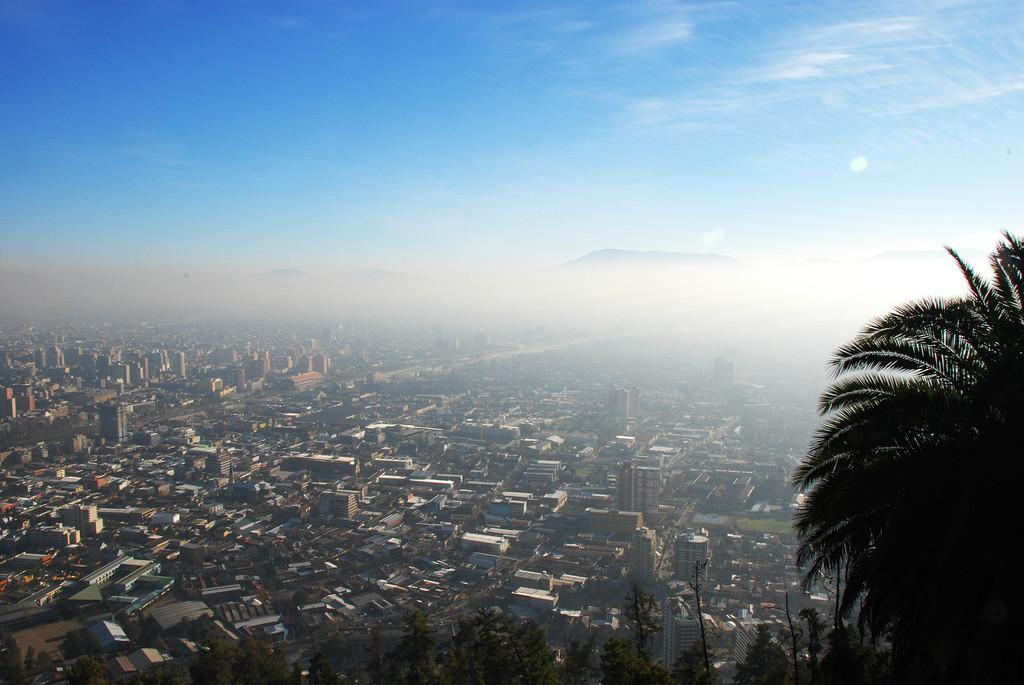What type of view is shown in the image? The image is an aerial view. What can be seen from this perspective? There is a city visible in the image. What else is visible in the image besides the city? The sky is visible in the image, and clouds are present in the sky. What type of vegetation can be seen at the bottom of the image? There are trees visible at the bottom of the image. What type of calendar is hanging on the wall in the image? There is no calendar present in the image; it is an aerial view of a city with trees, sky, and clouds. 